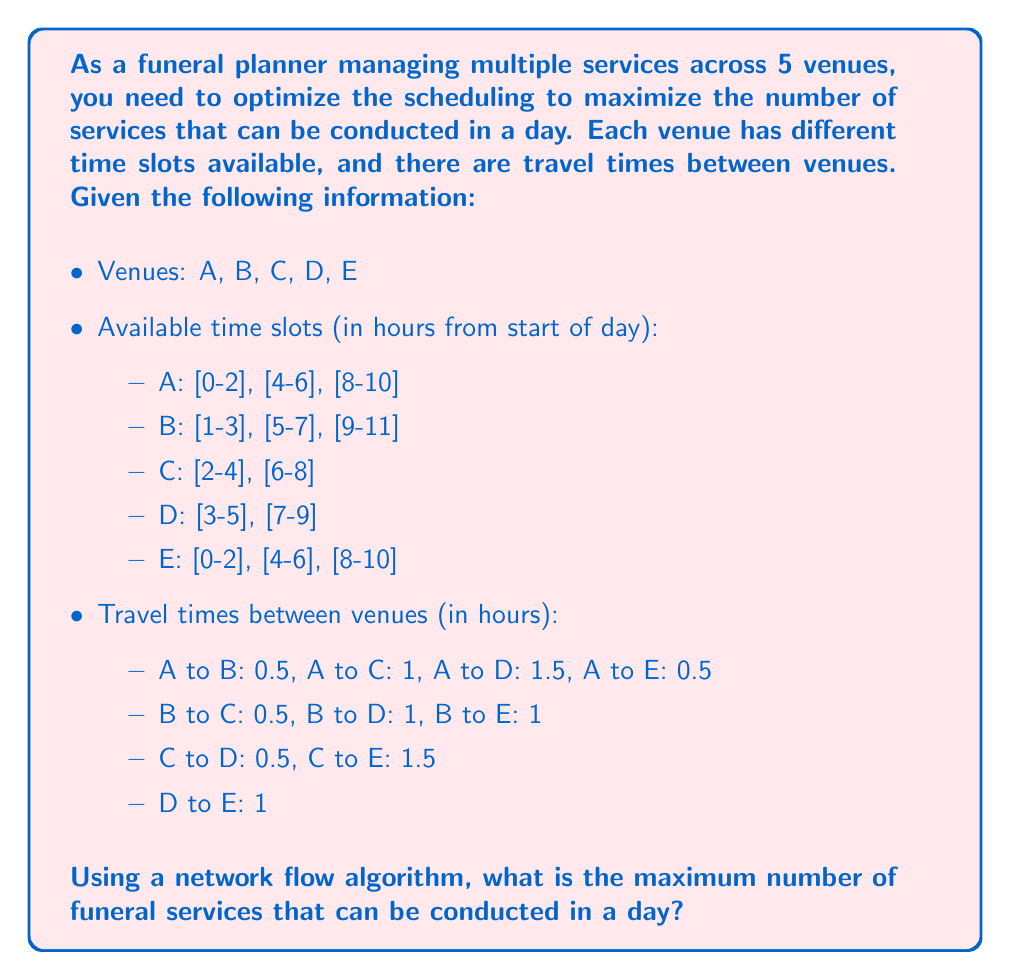Teach me how to tackle this problem. To solve this problem, we can use the Ford-Fulkerson algorithm for maximum flow in a network. Here's how we can approach it:

1. Construct a graph:
   - Create a source node (S) and a sink node (T)
   - For each venue and time slot, create a node (e.g., A0-2, A4-6, etc.)
   - Connect S to all first time slot nodes with capacity 1
   - Connect all last time slot nodes to T with capacity 1
   - Connect time slots within the same venue with capacity 1 if they're compatible (i.e., enough time between them)
   - Connect time slots between venues with capacity 1 if they're compatible (considering travel time)

2. Apply the Ford-Fulkerson algorithm to find the maximum flow from S to T.

Let's construct the graph:

[asy]
unitsize(100);
pair S = (-1,0), T = (6,0);
pair A02 = (0,2), A46 = (2,2), A810 = (4,2);
pair B13 = (1,1), B57 = (3,1), B911 = (5,1);
pair C24 = (1,0), C68 = (3,0);
pair D35 = (2,-1), D79 = (4,-1);
pair E02 = (0,-2), E46 = (2,-2), E810 = (4,-2);

draw(S--A02--A46--A810--T, arrow=Arrow);
draw(S--B13--B57--B911--T, arrow=Arrow);
draw(S--C24--C68--T, arrow=Arrow);
draw(S--D35--D79--T, arrow=Arrow);
draw(S--E02--E46--E810--T, arrow=Arrow);

draw(A02--B13--C24--D35, arrow=Arrow);
draw(A46--B57--C68--D79, arrow=Arrow);
draw(A810--B911, arrow=Arrow);

draw(B13--A46, arrow=Arrow);
draw(B57--A810, arrow=Arrow);
draw(C24--B57, arrow=Arrow);
draw(C68--B911, arrow=Arrow);
draw(D35--C68, arrow=Arrow);

draw(A02--E02, arrow=Arrow);
draw(A46--E46, arrow=Arrow);
draw(A810--E810, arrow=Arrow);

label("S", S, W);
label("T", T, E);
label("A0-2", A02, N);
label("A4-6", A46, N);
label("A8-10", A810, N);
label("B1-3", B13, N);
label("B5-7", B57, N);
label("B9-11", B911, N);
label("C2-4", C24, S);
label("C6-8", C68, S);
label("D3-5", D35, S);
label("D7-9", D79, S);
label("E0-2", E02, S);
label("E4-6", E46, S);
label("E8-10", E810, S);
[/asy]

Now, we apply the Ford-Fulkerson algorithm:

1. Find an augmenting path from S to T (e.g., S -> A0-2 -> B1-3 -> C2-4 -> D3-5 -> T)
2. Augment the flow along this path
3. Repeat until no augmenting path is found

After running the algorithm, we find that the maximum flow is 5, which corresponds to the following schedule:

1. A0-2
2. B1-3
3. C2-4
4. D3-5
5. E4-6

This schedule maximizes the number of funeral services that can be conducted in a day, taking into account the available time slots and travel times between venues.
Answer: The maximum number of funeral services that can be conducted in a day is 5. 